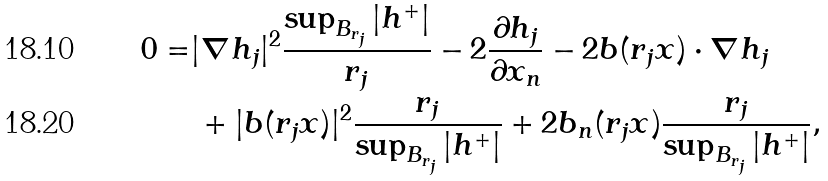<formula> <loc_0><loc_0><loc_500><loc_500>0 = & | \nabla h _ { j } | ^ { 2 } \frac { \sup _ { B _ { r _ { j } } } | h ^ { + } | } { r _ { j } } - 2 \frac { \partial h _ { j } } { \partial x _ { n } } - 2 b ( r _ { j } x ) \cdot \nabla h _ { j } \\ & \, + | b ( r _ { j } x ) | ^ { 2 } \frac { r _ { j } } { \sup _ { B _ { r _ { j } } } | h ^ { + } | } + 2 b _ { n } ( r _ { j } x ) \frac { r _ { j } } { \sup _ { B _ { r _ { j } } } | h ^ { + } | } ,</formula> 